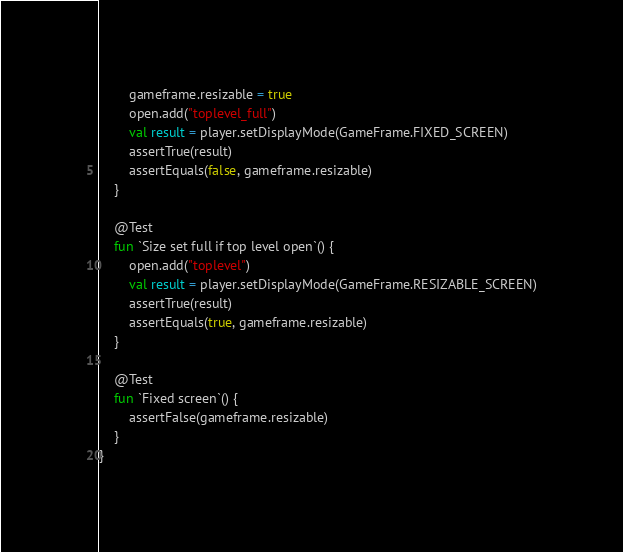Convert code to text. <code><loc_0><loc_0><loc_500><loc_500><_Kotlin_>        gameframe.resizable = true
        open.add("toplevel_full")
        val result = player.setDisplayMode(GameFrame.FIXED_SCREEN)
        assertTrue(result)
        assertEquals(false, gameframe.resizable)
    }

    @Test
    fun `Size set full if top level open`() {
        open.add("toplevel")
        val result = player.setDisplayMode(GameFrame.RESIZABLE_SCREEN)
        assertTrue(result)
        assertEquals(true, gameframe.resizable)
    }

    @Test
    fun `Fixed screen`() {
        assertFalse(gameframe.resizable)
    }
}
</code> 